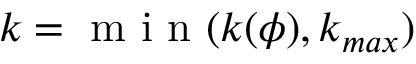<formula> <loc_0><loc_0><loc_500><loc_500>k = m i n ( k ( \phi ) , k _ { \max } )</formula> 